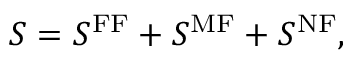Convert formula to latex. <formula><loc_0><loc_0><loc_500><loc_500>S = S ^ { F F } + S ^ { M F } + S ^ { N F } ,</formula> 